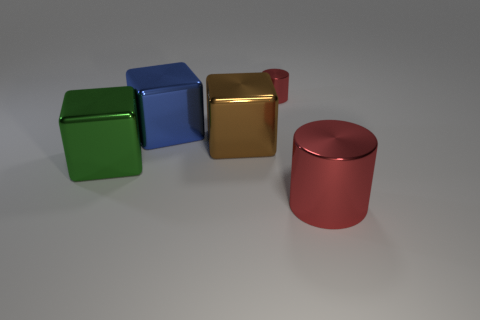Add 1 large brown metallic spheres. How many objects exist? 6 Subtract all blue blocks. How many blocks are left? 2 Subtract all red cylinders. How many yellow cubes are left? 0 Subtract all tiny red cylinders. Subtract all large cyan things. How many objects are left? 4 Add 1 large blue metallic blocks. How many large blue metallic blocks are left? 2 Add 5 large cubes. How many large cubes exist? 8 Subtract 0 purple blocks. How many objects are left? 5 Subtract all cylinders. How many objects are left? 3 Subtract 1 cylinders. How many cylinders are left? 1 Subtract all yellow blocks. Subtract all cyan cylinders. How many blocks are left? 3 